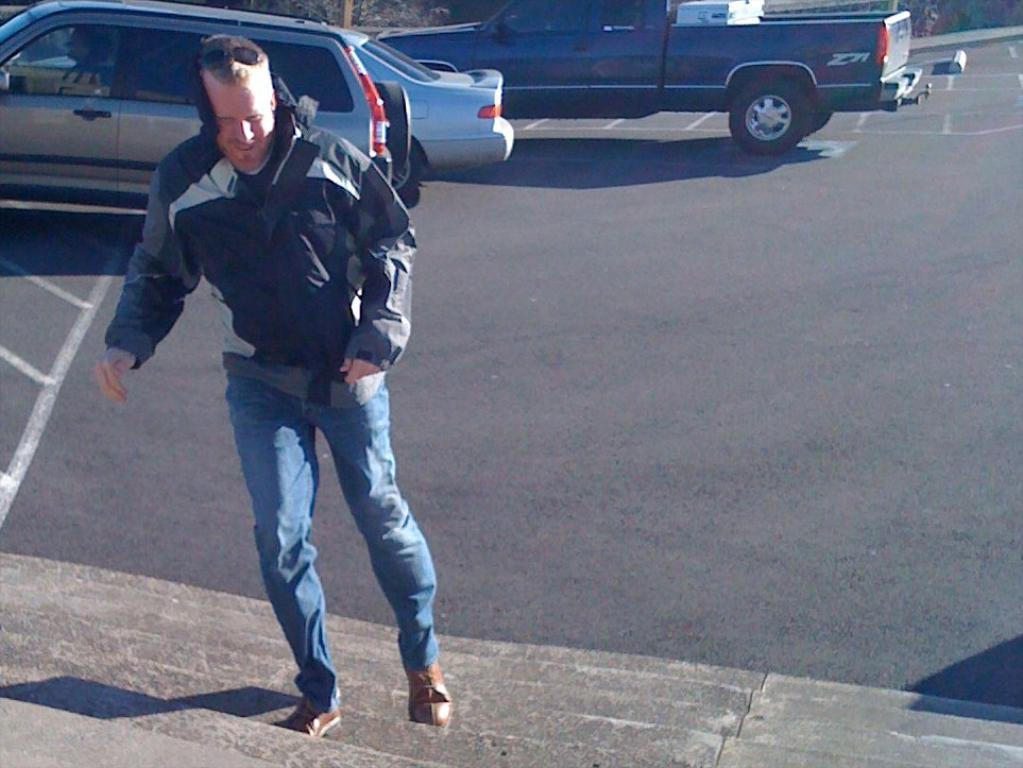What is the person in the image doing? The person in the image is climbing stairs. What can be seen in the background of the image? There are cars visible on the road in the background of the image. What type of twist can be seen in the person's hair in the image? There is no twist in the person's hair visible in the image. What kind of building is located near the person climbing stairs in the image? There is no building mentioned or visible in the image; it only features a person climbing stairs and cars on the road in the background. 